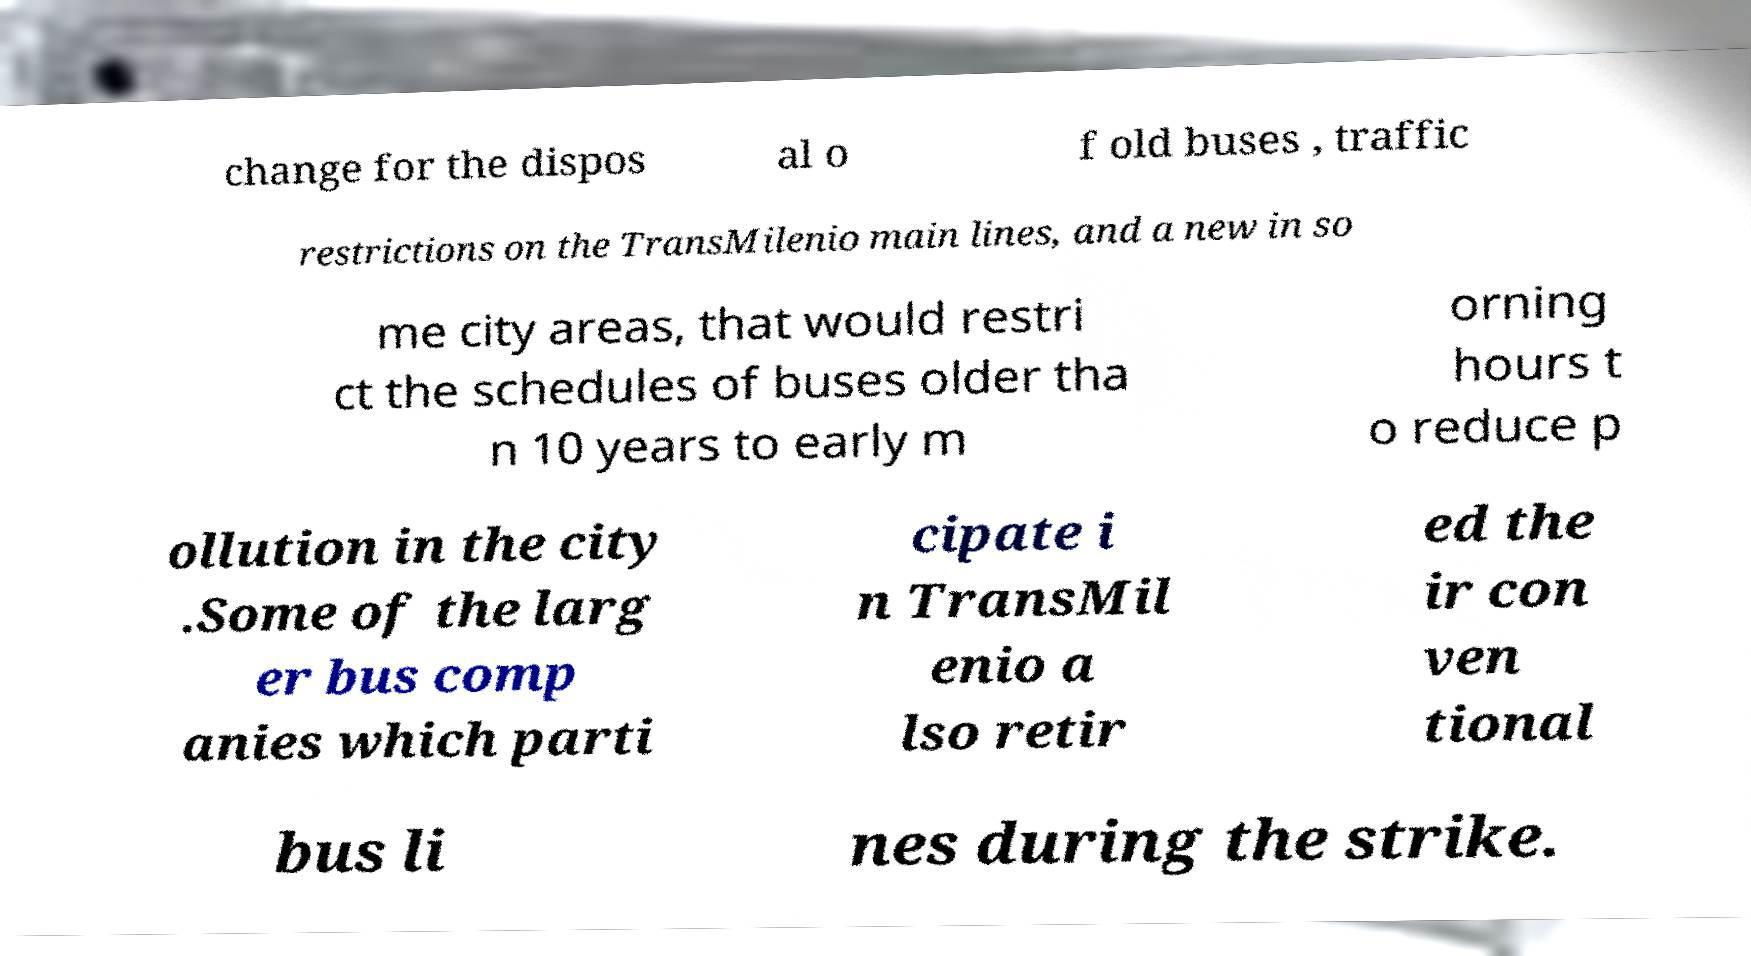Please read and relay the text visible in this image. What does it say? change for the dispos al o f old buses , traffic restrictions on the TransMilenio main lines, and a new in so me city areas, that would restri ct the schedules of buses older tha n 10 years to early m orning hours t o reduce p ollution in the city .Some of the larg er bus comp anies which parti cipate i n TransMil enio a lso retir ed the ir con ven tional bus li nes during the strike. 